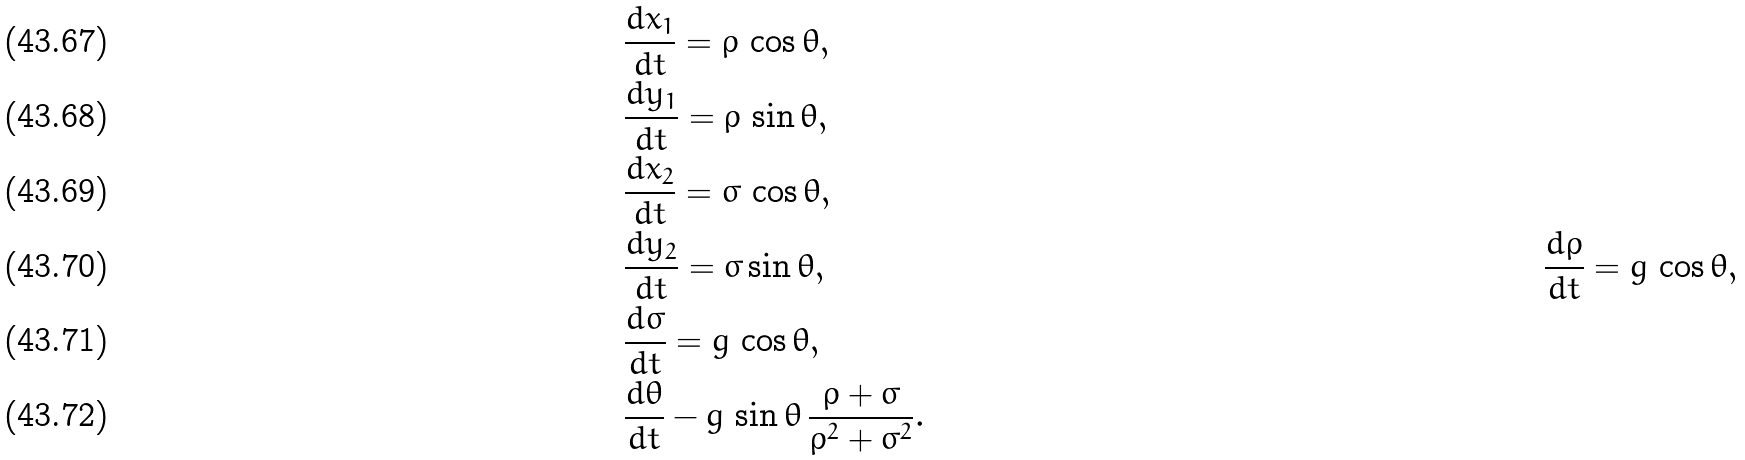Convert formula to latex. <formula><loc_0><loc_0><loc_500><loc_500>& \frac { d x _ { 1 } } { d t } = \rho \, \cos \theta , \\ & \frac { d y _ { 1 } } { d t } = \rho \, \sin \theta , \\ & \frac { d x _ { 2 } } { d t } = \sigma \, \cos \theta , \\ & \frac { d y _ { 2 } } { d t } = \sigma \sin \theta , \quad & \frac { d \rho } { d t } = g \, \cos \theta , \\ & \frac { d \sigma } { d t } = g \, \cos \theta , \\ & \frac { d \theta } { d t } - g \, \sin \theta \, \frac { \rho + \sigma } { \rho ^ { 2 } + \sigma ^ { 2 } } .</formula> 